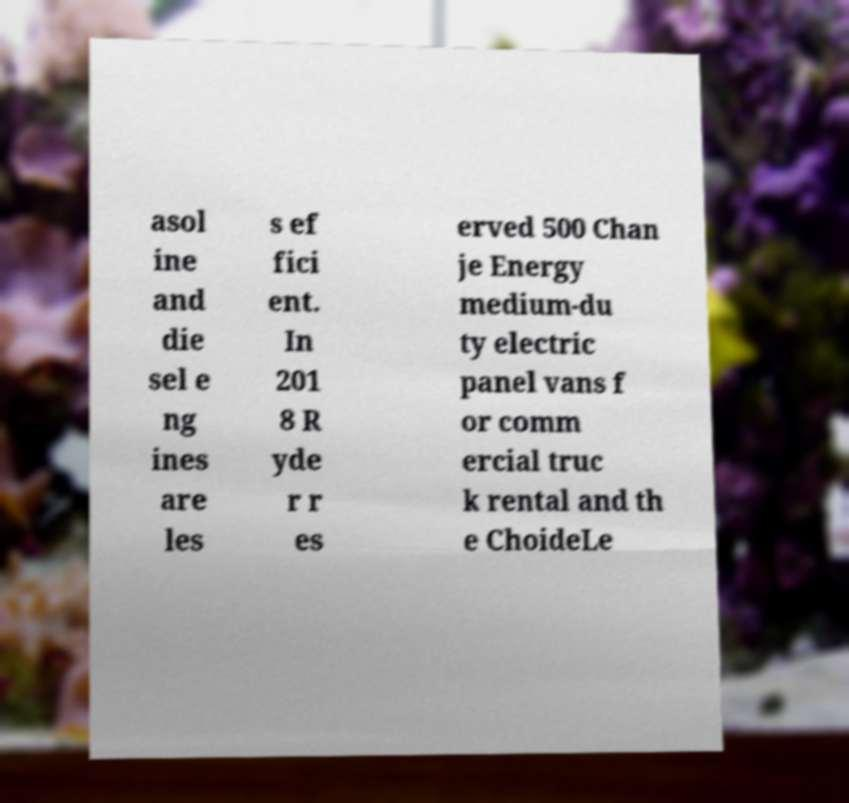For documentation purposes, I need the text within this image transcribed. Could you provide that? asol ine and die sel e ng ines are les s ef fici ent. In 201 8 R yde r r es erved 500 Chan je Energy medium-du ty electric panel vans f or comm ercial truc k rental and th e ChoideLe 